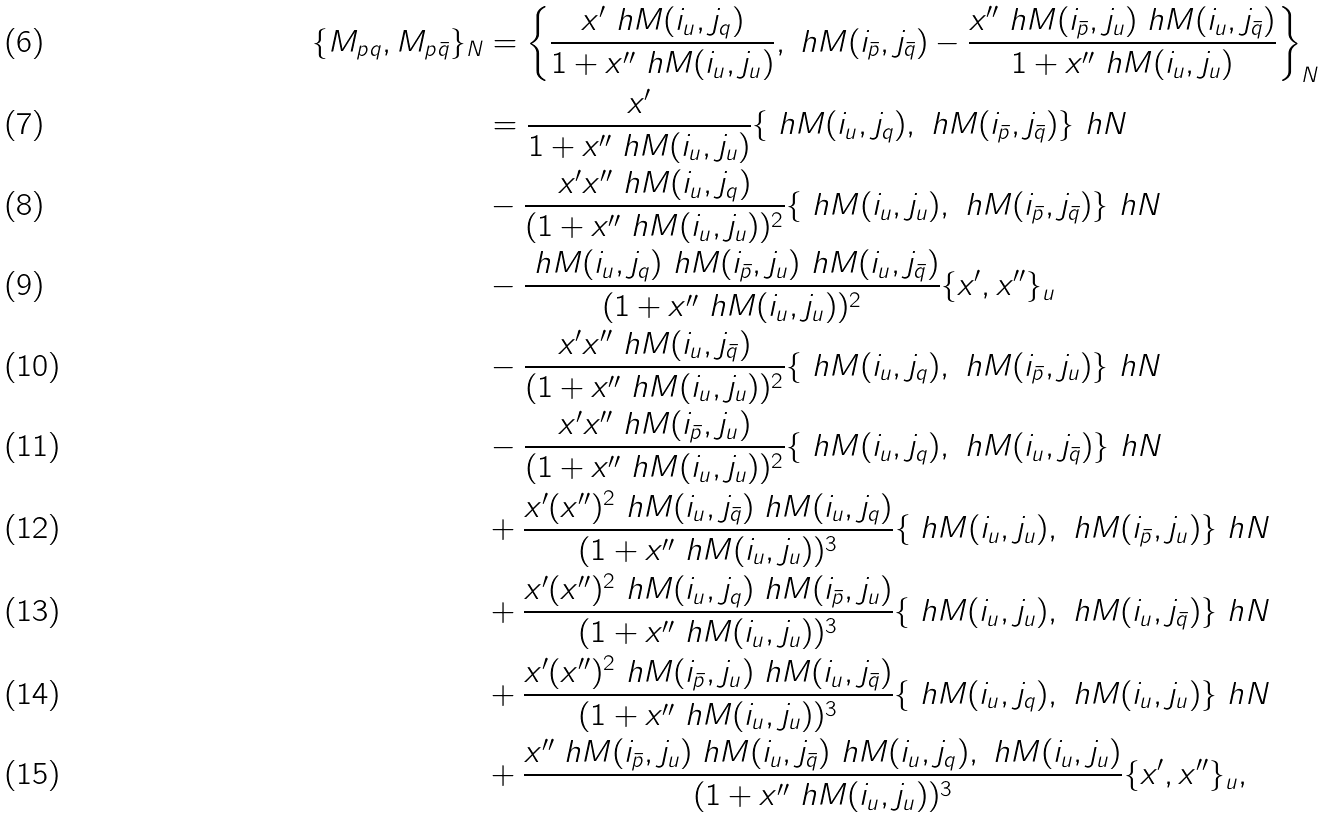<formula> <loc_0><loc_0><loc_500><loc_500>\{ M _ { p q } , M _ { p \bar { q } } \} _ { N } & = \left \{ \frac { x ^ { \prime } \ h M ( { i _ { u } } , j _ { q } ) } { 1 + x ^ { \prime \prime } \ h M ( { i _ { u } } , { j _ { u } } ) } , \ h M ( { i _ { \bar { p } } } , j _ { \bar { q } } ) - \frac { x ^ { \prime \prime } \ h M ( { i _ { \bar { p } } } , { j _ { u } } ) \ h M ( { i _ { u } } , j _ { \bar { q } } ) } { 1 + x ^ { \prime \prime } \ h M ( { i _ { u } } , { j _ { u } } ) } \right \} _ { N } \\ & = \frac { x ^ { \prime } } { 1 + x ^ { \prime \prime } \ h M ( { i _ { u } } , { j _ { u } } ) } \{ \ h M ( i _ { u } , j _ { q } ) , \ h M ( i _ { \bar { p } } , j _ { \bar { q } } ) \} _ { \ } h N \\ & - \frac { x ^ { \prime } x ^ { \prime \prime } \ h M ( i _ { u } , j _ { q } ) } { ( 1 + x ^ { \prime \prime } \ h M ( { i _ { u } } , { j _ { u } } ) ) ^ { 2 } } \{ \ h M ( i _ { u } , j _ { u } ) , \ h M ( i _ { \bar { p } } , j _ { \bar { q } } ) \} _ { \ } h N \\ & - \frac { \ h M ( { i _ { u } } , j _ { q } ) \ h M ( { i _ { \bar { p } } } , j _ { u } ) \ h M ( i _ { u } , j _ { \bar { q } } ) } { ( 1 + x ^ { \prime \prime } \ h M ( { i _ { u } } , { j _ { u } } ) ) ^ { 2 } } \{ x ^ { \prime } , x ^ { \prime \prime } \} _ { u } \\ & - \frac { x ^ { \prime } x ^ { \prime \prime } \ h M ( i _ { u } , j _ { \bar { q } } ) } { ( 1 + x ^ { \prime \prime } \ h M ( { i _ { u } } , { j _ { u } } ) ) ^ { 2 } } \{ \ h M ( i _ { u } , j _ { q } ) , \ h M ( i _ { \bar { p } } , j _ { u } ) \} _ { \ } h N \\ & - \frac { x ^ { \prime } x ^ { \prime \prime } \ h M ( i _ { \bar { p } } , j _ { u } ) } { ( 1 + x ^ { \prime \prime } \ h M ( { i _ { u } } , { j _ { u } } ) ) ^ { 2 } } \{ \ h M ( i _ { u } , j _ { q } ) , \ h M ( i _ { u } , j _ { \bar { q } } ) \} _ { \ } h N \\ & + \frac { x ^ { \prime } ( x ^ { \prime \prime } ) ^ { 2 } \ h M ( i _ { u } , j _ { \bar { q } } ) \ h M ( i _ { u } , j _ { q } ) } { ( 1 + x ^ { \prime \prime } \ h M ( { i _ { u } } , { j _ { u } } ) ) ^ { 3 } } \{ \ h M ( i _ { u } , j _ { u } ) , \ h M ( i _ { \bar { p } } , j _ { u } ) \} _ { \ } h N \\ & + \frac { x ^ { \prime } ( x ^ { \prime \prime } ) ^ { 2 } \ h M ( i _ { u } , j _ { q } ) \ h M ( i _ { \bar { p } } , j _ { u } ) } { ( 1 + x ^ { \prime \prime } \ h M ( { i _ { u } } , { j _ { u } } ) ) ^ { 3 } } \{ \ h M ( i _ { u } , j _ { u } ) , \ h M ( i _ { u } , j _ { \bar { q } } ) \} _ { \ } h N \\ & + \frac { x ^ { \prime } ( x ^ { \prime \prime } ) ^ { 2 } \ h M ( i _ { \bar { p } } , j _ { u } ) \ h M ( i _ { u } , j _ { \bar { q } } ) } { ( 1 + x ^ { \prime \prime } \ h M ( { i _ { u } } , { j _ { u } } ) ) ^ { 3 } } \{ \ h M ( i _ { u } , j _ { q } ) , \ h M ( i _ { u } , j _ { u } ) \} _ { \ } h N \\ & + \frac { x ^ { \prime \prime } \ h M ( i _ { \bar { p } } , j _ { u } ) \ h M ( i _ { u } , j _ { \bar { q } } ) \ h M ( i _ { u } , j _ { q } ) , \ h M ( i _ { u } , j _ { u } ) } { ( 1 + x ^ { \prime \prime } \ h M ( { i _ { u } } , { j _ { u } } ) ) ^ { 3 } } \{ x ^ { \prime } , x ^ { \prime \prime } \} _ { u } ,</formula> 